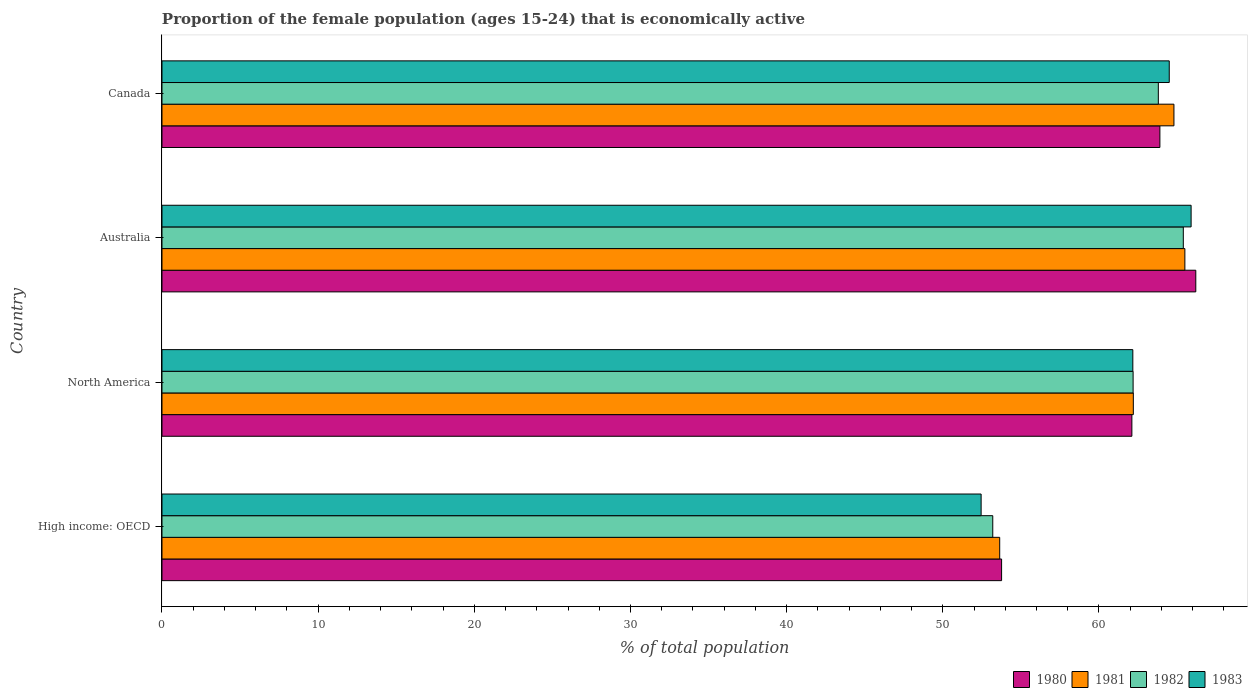How many groups of bars are there?
Make the answer very short. 4. Are the number of bars on each tick of the Y-axis equal?
Keep it short and to the point. Yes. How many bars are there on the 1st tick from the bottom?
Offer a very short reply. 4. What is the proportion of the female population that is economically active in 1980 in Canada?
Provide a short and direct response. 63.9. Across all countries, what is the maximum proportion of the female population that is economically active in 1980?
Provide a short and direct response. 66.2. Across all countries, what is the minimum proportion of the female population that is economically active in 1982?
Keep it short and to the point. 53.2. In which country was the proportion of the female population that is economically active in 1981 minimum?
Offer a terse response. High income: OECD. What is the total proportion of the female population that is economically active in 1983 in the graph?
Provide a short and direct response. 245.02. What is the difference between the proportion of the female population that is economically active in 1982 in Australia and that in North America?
Your answer should be very brief. 3.21. What is the difference between the proportion of the female population that is economically active in 1983 in North America and the proportion of the female population that is economically active in 1982 in Canada?
Provide a succinct answer. -1.63. What is the average proportion of the female population that is economically active in 1983 per country?
Offer a terse response. 61.26. What is the difference between the proportion of the female population that is economically active in 1983 and proportion of the female population that is economically active in 1980 in High income: OECD?
Keep it short and to the point. -1.31. In how many countries, is the proportion of the female population that is economically active in 1982 greater than 26 %?
Your answer should be compact. 4. What is the ratio of the proportion of the female population that is economically active in 1981 in Canada to that in High income: OECD?
Provide a succinct answer. 1.21. Is the proportion of the female population that is economically active in 1981 in Canada less than that in High income: OECD?
Offer a very short reply. No. What is the difference between the highest and the second highest proportion of the female population that is economically active in 1983?
Offer a very short reply. 1.4. What is the difference between the highest and the lowest proportion of the female population that is economically active in 1981?
Your response must be concise. 11.86. Is it the case that in every country, the sum of the proportion of the female population that is economically active in 1981 and proportion of the female population that is economically active in 1983 is greater than the sum of proportion of the female population that is economically active in 1982 and proportion of the female population that is economically active in 1980?
Your answer should be compact. No. What does the 4th bar from the top in Australia represents?
Your answer should be compact. 1980. Are all the bars in the graph horizontal?
Offer a very short reply. Yes. How many countries are there in the graph?
Make the answer very short. 4. What is the difference between two consecutive major ticks on the X-axis?
Your answer should be very brief. 10. Are the values on the major ticks of X-axis written in scientific E-notation?
Offer a terse response. No. Does the graph contain any zero values?
Offer a very short reply. No. Where does the legend appear in the graph?
Ensure brevity in your answer.  Bottom right. What is the title of the graph?
Offer a terse response. Proportion of the female population (ages 15-24) that is economically active. Does "2015" appear as one of the legend labels in the graph?
Ensure brevity in your answer.  No. What is the label or title of the X-axis?
Offer a very short reply. % of total population. What is the % of total population of 1980 in High income: OECD?
Give a very brief answer. 53.76. What is the % of total population in 1981 in High income: OECD?
Your answer should be very brief. 53.64. What is the % of total population of 1982 in High income: OECD?
Your answer should be compact. 53.2. What is the % of total population of 1983 in High income: OECD?
Give a very brief answer. 52.45. What is the % of total population of 1980 in North America?
Offer a very short reply. 62.11. What is the % of total population of 1981 in North America?
Your answer should be very brief. 62.2. What is the % of total population of 1982 in North America?
Your response must be concise. 62.19. What is the % of total population in 1983 in North America?
Your answer should be compact. 62.17. What is the % of total population in 1980 in Australia?
Make the answer very short. 66.2. What is the % of total population in 1981 in Australia?
Offer a very short reply. 65.5. What is the % of total population in 1982 in Australia?
Offer a terse response. 65.4. What is the % of total population in 1983 in Australia?
Ensure brevity in your answer.  65.9. What is the % of total population in 1980 in Canada?
Your response must be concise. 63.9. What is the % of total population of 1981 in Canada?
Give a very brief answer. 64.8. What is the % of total population in 1982 in Canada?
Ensure brevity in your answer.  63.8. What is the % of total population of 1983 in Canada?
Your response must be concise. 64.5. Across all countries, what is the maximum % of total population in 1980?
Offer a terse response. 66.2. Across all countries, what is the maximum % of total population in 1981?
Your response must be concise. 65.5. Across all countries, what is the maximum % of total population in 1982?
Your answer should be compact. 65.4. Across all countries, what is the maximum % of total population of 1983?
Ensure brevity in your answer.  65.9. Across all countries, what is the minimum % of total population of 1980?
Make the answer very short. 53.76. Across all countries, what is the minimum % of total population of 1981?
Provide a succinct answer. 53.64. Across all countries, what is the minimum % of total population in 1982?
Make the answer very short. 53.2. Across all countries, what is the minimum % of total population in 1983?
Your answer should be compact. 52.45. What is the total % of total population of 1980 in the graph?
Your response must be concise. 245.97. What is the total % of total population in 1981 in the graph?
Offer a very short reply. 246.14. What is the total % of total population of 1982 in the graph?
Provide a succinct answer. 244.58. What is the total % of total population of 1983 in the graph?
Make the answer very short. 245.02. What is the difference between the % of total population in 1980 in High income: OECD and that in North America?
Your response must be concise. -8.34. What is the difference between the % of total population of 1981 in High income: OECD and that in North America?
Provide a short and direct response. -8.56. What is the difference between the % of total population in 1982 in High income: OECD and that in North America?
Give a very brief answer. -8.99. What is the difference between the % of total population of 1983 in High income: OECD and that in North America?
Keep it short and to the point. -9.71. What is the difference between the % of total population in 1980 in High income: OECD and that in Australia?
Provide a short and direct response. -12.44. What is the difference between the % of total population in 1981 in High income: OECD and that in Australia?
Ensure brevity in your answer.  -11.86. What is the difference between the % of total population in 1982 in High income: OECD and that in Australia?
Your answer should be very brief. -12.2. What is the difference between the % of total population in 1983 in High income: OECD and that in Australia?
Your answer should be very brief. -13.45. What is the difference between the % of total population of 1980 in High income: OECD and that in Canada?
Your answer should be very brief. -10.14. What is the difference between the % of total population of 1981 in High income: OECD and that in Canada?
Ensure brevity in your answer.  -11.16. What is the difference between the % of total population in 1982 in High income: OECD and that in Canada?
Keep it short and to the point. -10.6. What is the difference between the % of total population in 1983 in High income: OECD and that in Canada?
Provide a succinct answer. -12.05. What is the difference between the % of total population of 1980 in North America and that in Australia?
Offer a terse response. -4.09. What is the difference between the % of total population in 1981 in North America and that in Australia?
Offer a terse response. -3.3. What is the difference between the % of total population of 1982 in North America and that in Australia?
Give a very brief answer. -3.21. What is the difference between the % of total population of 1983 in North America and that in Australia?
Provide a short and direct response. -3.73. What is the difference between the % of total population of 1980 in North America and that in Canada?
Your answer should be compact. -1.79. What is the difference between the % of total population of 1981 in North America and that in Canada?
Ensure brevity in your answer.  -2.6. What is the difference between the % of total population of 1982 in North America and that in Canada?
Give a very brief answer. -1.61. What is the difference between the % of total population in 1983 in North America and that in Canada?
Your answer should be very brief. -2.33. What is the difference between the % of total population of 1981 in Australia and that in Canada?
Give a very brief answer. 0.7. What is the difference between the % of total population of 1980 in High income: OECD and the % of total population of 1981 in North America?
Give a very brief answer. -8.44. What is the difference between the % of total population of 1980 in High income: OECD and the % of total population of 1982 in North America?
Provide a succinct answer. -8.42. What is the difference between the % of total population of 1980 in High income: OECD and the % of total population of 1983 in North America?
Offer a very short reply. -8.4. What is the difference between the % of total population of 1981 in High income: OECD and the % of total population of 1982 in North America?
Ensure brevity in your answer.  -8.54. What is the difference between the % of total population in 1981 in High income: OECD and the % of total population in 1983 in North America?
Provide a succinct answer. -8.52. What is the difference between the % of total population in 1982 in High income: OECD and the % of total population in 1983 in North America?
Your answer should be compact. -8.97. What is the difference between the % of total population in 1980 in High income: OECD and the % of total population in 1981 in Australia?
Your answer should be compact. -11.74. What is the difference between the % of total population of 1980 in High income: OECD and the % of total population of 1982 in Australia?
Offer a terse response. -11.64. What is the difference between the % of total population in 1980 in High income: OECD and the % of total population in 1983 in Australia?
Your answer should be very brief. -12.14. What is the difference between the % of total population in 1981 in High income: OECD and the % of total population in 1982 in Australia?
Offer a very short reply. -11.76. What is the difference between the % of total population in 1981 in High income: OECD and the % of total population in 1983 in Australia?
Offer a terse response. -12.26. What is the difference between the % of total population in 1982 in High income: OECD and the % of total population in 1983 in Australia?
Ensure brevity in your answer.  -12.7. What is the difference between the % of total population in 1980 in High income: OECD and the % of total population in 1981 in Canada?
Offer a terse response. -11.04. What is the difference between the % of total population in 1980 in High income: OECD and the % of total population in 1982 in Canada?
Keep it short and to the point. -10.04. What is the difference between the % of total population of 1980 in High income: OECD and the % of total population of 1983 in Canada?
Ensure brevity in your answer.  -10.74. What is the difference between the % of total population in 1981 in High income: OECD and the % of total population in 1982 in Canada?
Your response must be concise. -10.16. What is the difference between the % of total population in 1981 in High income: OECD and the % of total population in 1983 in Canada?
Give a very brief answer. -10.86. What is the difference between the % of total population in 1982 in High income: OECD and the % of total population in 1983 in Canada?
Provide a short and direct response. -11.3. What is the difference between the % of total population in 1980 in North America and the % of total population in 1981 in Australia?
Your answer should be very brief. -3.39. What is the difference between the % of total population in 1980 in North America and the % of total population in 1982 in Australia?
Your response must be concise. -3.29. What is the difference between the % of total population of 1980 in North America and the % of total population of 1983 in Australia?
Your answer should be very brief. -3.79. What is the difference between the % of total population of 1981 in North America and the % of total population of 1982 in Australia?
Your answer should be very brief. -3.2. What is the difference between the % of total population in 1981 in North America and the % of total population in 1983 in Australia?
Provide a short and direct response. -3.7. What is the difference between the % of total population of 1982 in North America and the % of total population of 1983 in Australia?
Provide a short and direct response. -3.71. What is the difference between the % of total population of 1980 in North America and the % of total population of 1981 in Canada?
Your response must be concise. -2.69. What is the difference between the % of total population of 1980 in North America and the % of total population of 1982 in Canada?
Your response must be concise. -1.69. What is the difference between the % of total population in 1980 in North America and the % of total population in 1983 in Canada?
Give a very brief answer. -2.39. What is the difference between the % of total population in 1981 in North America and the % of total population in 1982 in Canada?
Ensure brevity in your answer.  -1.6. What is the difference between the % of total population in 1981 in North America and the % of total population in 1983 in Canada?
Keep it short and to the point. -2.3. What is the difference between the % of total population in 1982 in North America and the % of total population in 1983 in Canada?
Your response must be concise. -2.31. What is the difference between the % of total population of 1980 in Australia and the % of total population of 1981 in Canada?
Your answer should be very brief. 1.4. What is the difference between the % of total population in 1980 in Australia and the % of total population in 1983 in Canada?
Provide a short and direct response. 1.7. What is the average % of total population in 1980 per country?
Provide a short and direct response. 61.49. What is the average % of total population in 1981 per country?
Make the answer very short. 61.54. What is the average % of total population in 1982 per country?
Provide a succinct answer. 61.15. What is the average % of total population in 1983 per country?
Make the answer very short. 61.26. What is the difference between the % of total population of 1980 and % of total population of 1981 in High income: OECD?
Your answer should be compact. 0.12. What is the difference between the % of total population of 1980 and % of total population of 1982 in High income: OECD?
Your answer should be very brief. 0.57. What is the difference between the % of total population in 1980 and % of total population in 1983 in High income: OECD?
Provide a succinct answer. 1.31. What is the difference between the % of total population of 1981 and % of total population of 1982 in High income: OECD?
Keep it short and to the point. 0.44. What is the difference between the % of total population of 1981 and % of total population of 1983 in High income: OECD?
Offer a terse response. 1.19. What is the difference between the % of total population of 1982 and % of total population of 1983 in High income: OECD?
Make the answer very short. 0.75. What is the difference between the % of total population of 1980 and % of total population of 1981 in North America?
Your response must be concise. -0.09. What is the difference between the % of total population in 1980 and % of total population in 1982 in North America?
Ensure brevity in your answer.  -0.08. What is the difference between the % of total population in 1980 and % of total population in 1983 in North America?
Keep it short and to the point. -0.06. What is the difference between the % of total population in 1981 and % of total population in 1982 in North America?
Provide a short and direct response. 0.01. What is the difference between the % of total population of 1981 and % of total population of 1983 in North America?
Provide a short and direct response. 0.03. What is the difference between the % of total population of 1982 and % of total population of 1983 in North America?
Provide a succinct answer. 0.02. What is the difference between the % of total population of 1980 and % of total population of 1983 in Australia?
Give a very brief answer. 0.3. What is the difference between the % of total population in 1981 and % of total population in 1982 in Australia?
Your answer should be compact. 0.1. What is the difference between the % of total population in 1982 and % of total population in 1983 in Australia?
Give a very brief answer. -0.5. What is the difference between the % of total population in 1980 and % of total population in 1981 in Canada?
Make the answer very short. -0.9. What is the difference between the % of total population of 1980 and % of total population of 1983 in Canada?
Provide a succinct answer. -0.6. What is the ratio of the % of total population in 1980 in High income: OECD to that in North America?
Give a very brief answer. 0.87. What is the ratio of the % of total population of 1981 in High income: OECD to that in North America?
Your response must be concise. 0.86. What is the ratio of the % of total population of 1982 in High income: OECD to that in North America?
Ensure brevity in your answer.  0.86. What is the ratio of the % of total population of 1983 in High income: OECD to that in North America?
Your answer should be very brief. 0.84. What is the ratio of the % of total population of 1980 in High income: OECD to that in Australia?
Keep it short and to the point. 0.81. What is the ratio of the % of total population in 1981 in High income: OECD to that in Australia?
Keep it short and to the point. 0.82. What is the ratio of the % of total population in 1982 in High income: OECD to that in Australia?
Offer a terse response. 0.81. What is the ratio of the % of total population in 1983 in High income: OECD to that in Australia?
Give a very brief answer. 0.8. What is the ratio of the % of total population of 1980 in High income: OECD to that in Canada?
Offer a terse response. 0.84. What is the ratio of the % of total population in 1981 in High income: OECD to that in Canada?
Offer a very short reply. 0.83. What is the ratio of the % of total population in 1982 in High income: OECD to that in Canada?
Make the answer very short. 0.83. What is the ratio of the % of total population in 1983 in High income: OECD to that in Canada?
Offer a very short reply. 0.81. What is the ratio of the % of total population in 1980 in North America to that in Australia?
Provide a short and direct response. 0.94. What is the ratio of the % of total population in 1981 in North America to that in Australia?
Provide a succinct answer. 0.95. What is the ratio of the % of total population of 1982 in North America to that in Australia?
Offer a very short reply. 0.95. What is the ratio of the % of total population in 1983 in North America to that in Australia?
Provide a short and direct response. 0.94. What is the ratio of the % of total population of 1980 in North America to that in Canada?
Provide a short and direct response. 0.97. What is the ratio of the % of total population in 1981 in North America to that in Canada?
Give a very brief answer. 0.96. What is the ratio of the % of total population of 1982 in North America to that in Canada?
Ensure brevity in your answer.  0.97. What is the ratio of the % of total population of 1983 in North America to that in Canada?
Provide a succinct answer. 0.96. What is the ratio of the % of total population in 1980 in Australia to that in Canada?
Provide a succinct answer. 1.04. What is the ratio of the % of total population of 1981 in Australia to that in Canada?
Make the answer very short. 1.01. What is the ratio of the % of total population of 1982 in Australia to that in Canada?
Offer a very short reply. 1.03. What is the ratio of the % of total population of 1983 in Australia to that in Canada?
Provide a succinct answer. 1.02. What is the difference between the highest and the second highest % of total population in 1980?
Ensure brevity in your answer.  2.3. What is the difference between the highest and the second highest % of total population of 1981?
Provide a succinct answer. 0.7. What is the difference between the highest and the second highest % of total population of 1982?
Provide a succinct answer. 1.6. What is the difference between the highest and the second highest % of total population in 1983?
Your response must be concise. 1.4. What is the difference between the highest and the lowest % of total population in 1980?
Offer a very short reply. 12.44. What is the difference between the highest and the lowest % of total population in 1981?
Provide a short and direct response. 11.86. What is the difference between the highest and the lowest % of total population of 1982?
Provide a short and direct response. 12.2. What is the difference between the highest and the lowest % of total population of 1983?
Your answer should be compact. 13.45. 